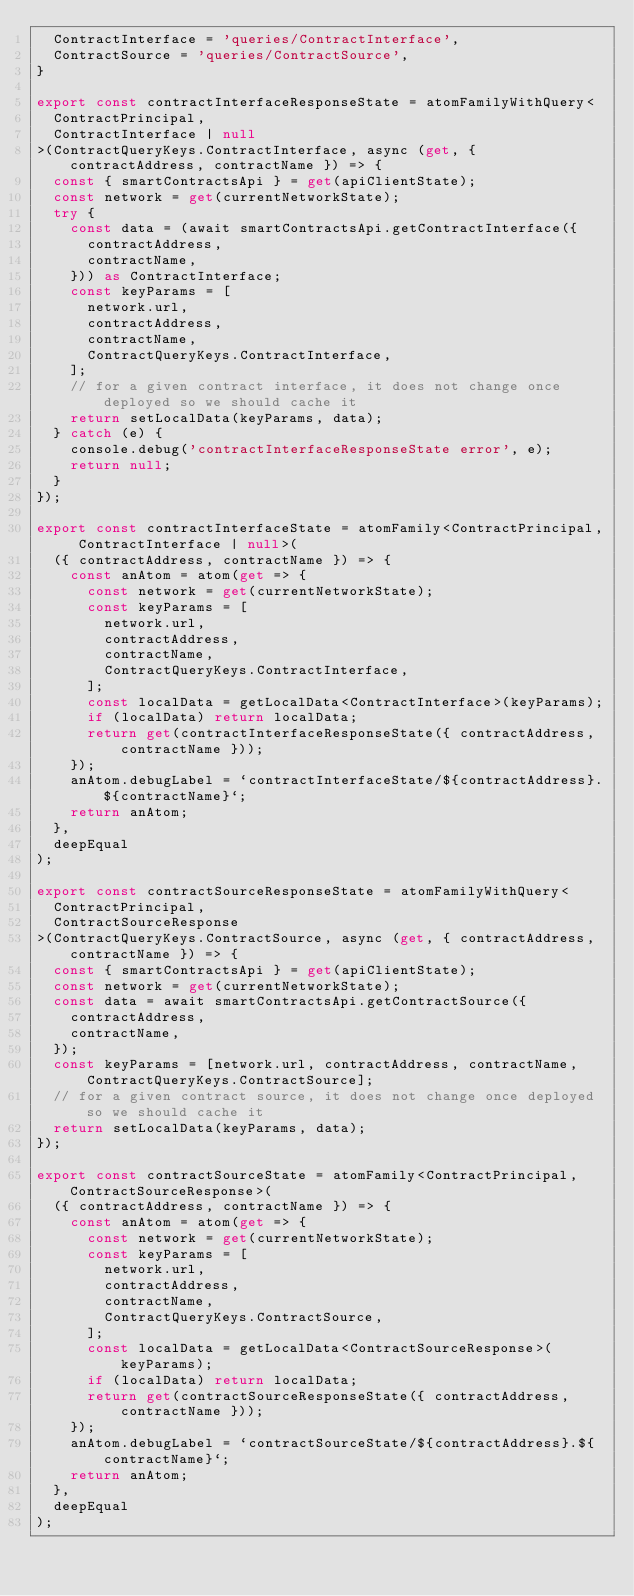<code> <loc_0><loc_0><loc_500><loc_500><_TypeScript_>  ContractInterface = 'queries/ContractInterface',
  ContractSource = 'queries/ContractSource',
}

export const contractInterfaceResponseState = atomFamilyWithQuery<
  ContractPrincipal,
  ContractInterface | null
>(ContractQueryKeys.ContractInterface, async (get, { contractAddress, contractName }) => {
  const { smartContractsApi } = get(apiClientState);
  const network = get(currentNetworkState);
  try {
    const data = (await smartContractsApi.getContractInterface({
      contractAddress,
      contractName,
    })) as ContractInterface;
    const keyParams = [
      network.url,
      contractAddress,
      contractName,
      ContractQueryKeys.ContractInterface,
    ];
    // for a given contract interface, it does not change once deployed so we should cache it
    return setLocalData(keyParams, data);
  } catch (e) {
    console.debug('contractInterfaceResponseState error', e);
    return null;
  }
});

export const contractInterfaceState = atomFamily<ContractPrincipal, ContractInterface | null>(
  ({ contractAddress, contractName }) => {
    const anAtom = atom(get => {
      const network = get(currentNetworkState);
      const keyParams = [
        network.url,
        contractAddress,
        contractName,
        ContractQueryKeys.ContractInterface,
      ];
      const localData = getLocalData<ContractInterface>(keyParams);
      if (localData) return localData;
      return get(contractInterfaceResponseState({ contractAddress, contractName }));
    });
    anAtom.debugLabel = `contractInterfaceState/${contractAddress}.${contractName}`;
    return anAtom;
  },
  deepEqual
);

export const contractSourceResponseState = atomFamilyWithQuery<
  ContractPrincipal,
  ContractSourceResponse
>(ContractQueryKeys.ContractSource, async (get, { contractAddress, contractName }) => {
  const { smartContractsApi } = get(apiClientState);
  const network = get(currentNetworkState);
  const data = await smartContractsApi.getContractSource({
    contractAddress,
    contractName,
  });
  const keyParams = [network.url, contractAddress, contractName, ContractQueryKeys.ContractSource];
  // for a given contract source, it does not change once deployed so we should cache it
  return setLocalData(keyParams, data);
});

export const contractSourceState = atomFamily<ContractPrincipal, ContractSourceResponse>(
  ({ contractAddress, contractName }) => {
    const anAtom = atom(get => {
      const network = get(currentNetworkState);
      const keyParams = [
        network.url,
        contractAddress,
        contractName,
        ContractQueryKeys.ContractSource,
      ];
      const localData = getLocalData<ContractSourceResponse>(keyParams);
      if (localData) return localData;
      return get(contractSourceResponseState({ contractAddress, contractName }));
    });
    anAtom.debugLabel = `contractSourceState/${contractAddress}.${contractName}`;
    return anAtom;
  },
  deepEqual
);
</code> 